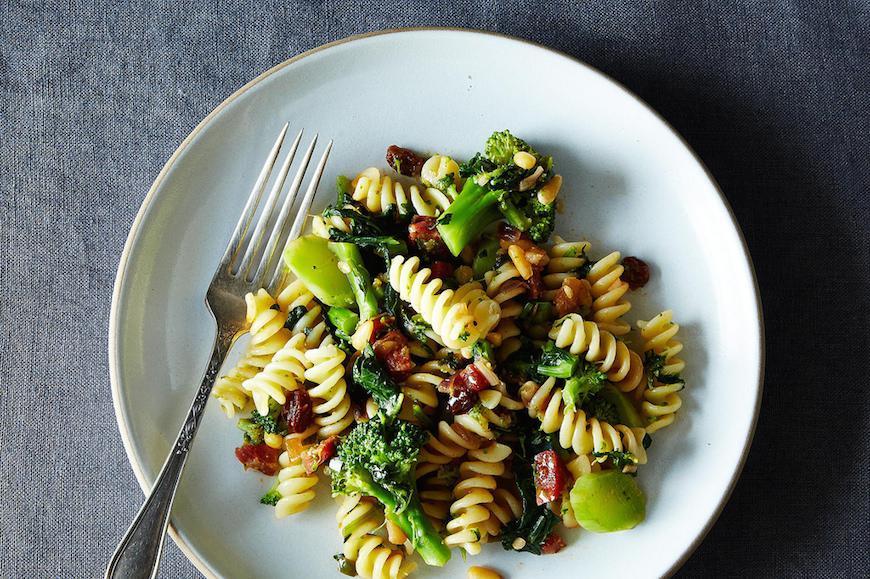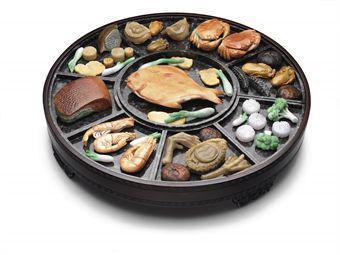The first image is the image on the left, the second image is the image on the right. For the images displayed, is the sentence "An image shows two silverware utensils on a white napkin next to a broccoli dish." factually correct? Answer yes or no. No. The first image is the image on the left, the second image is the image on the right. Given the left and right images, does the statement "One of the dishes contains broccoli and spiral pasta." hold true? Answer yes or no. Yes. 